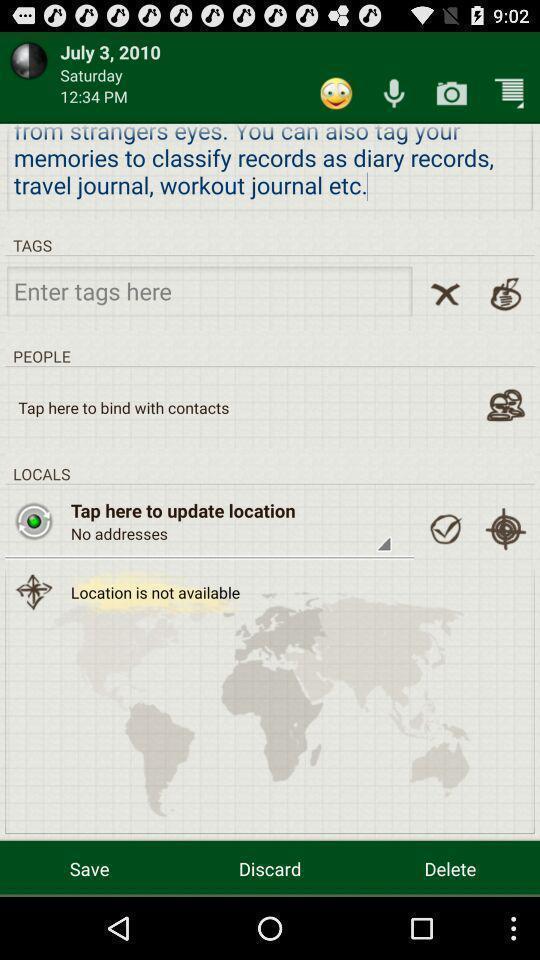What is the overall content of this screenshot? Screen showing various options in entertainment app. 